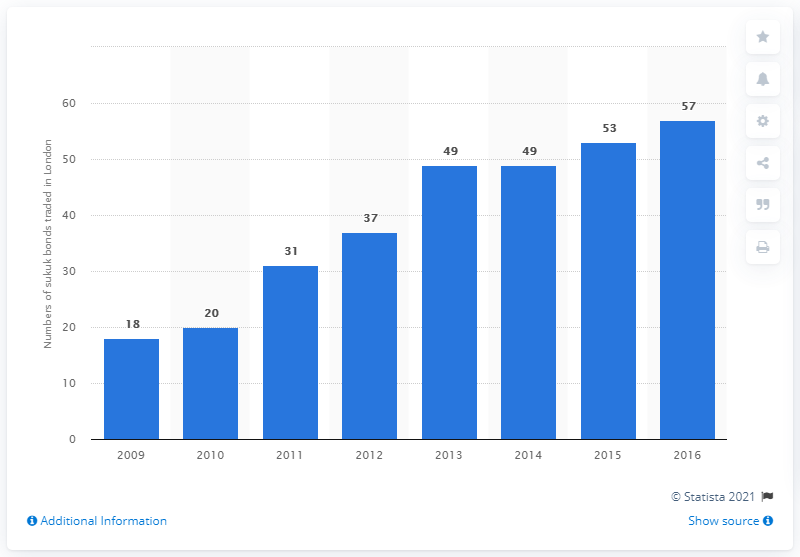Mention a couple of crucial points in this snapshot. In 2009, a total of 18 sukuk bonds were traded. In the year 2016, London was the leading center for Islamic finance in Western Europe. 